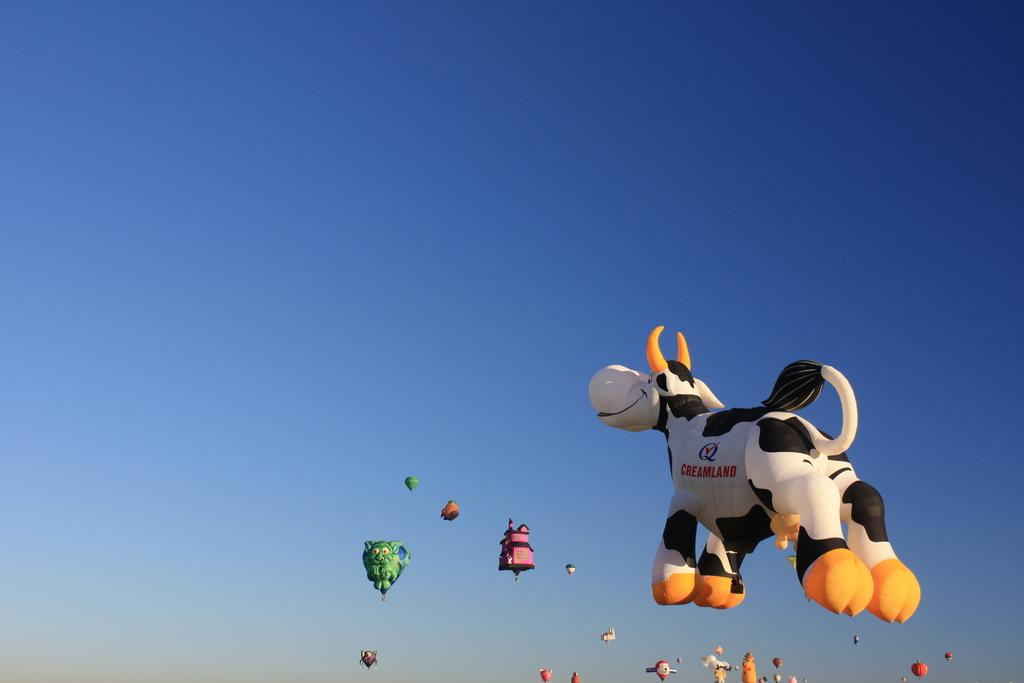What type of objects are in the sky in the image? There are several designed balloons in the image. What are the balloons doing in the image? The balloons are flying in the sky. Can you describe the balloon in the foreground of the image? There is a balloon in the shape of a cow in the foreground of the image. What type of glove is being worn by the cow balloon in the image? There is no glove present in the image, as it features balloons, not animals wearing gloves. 